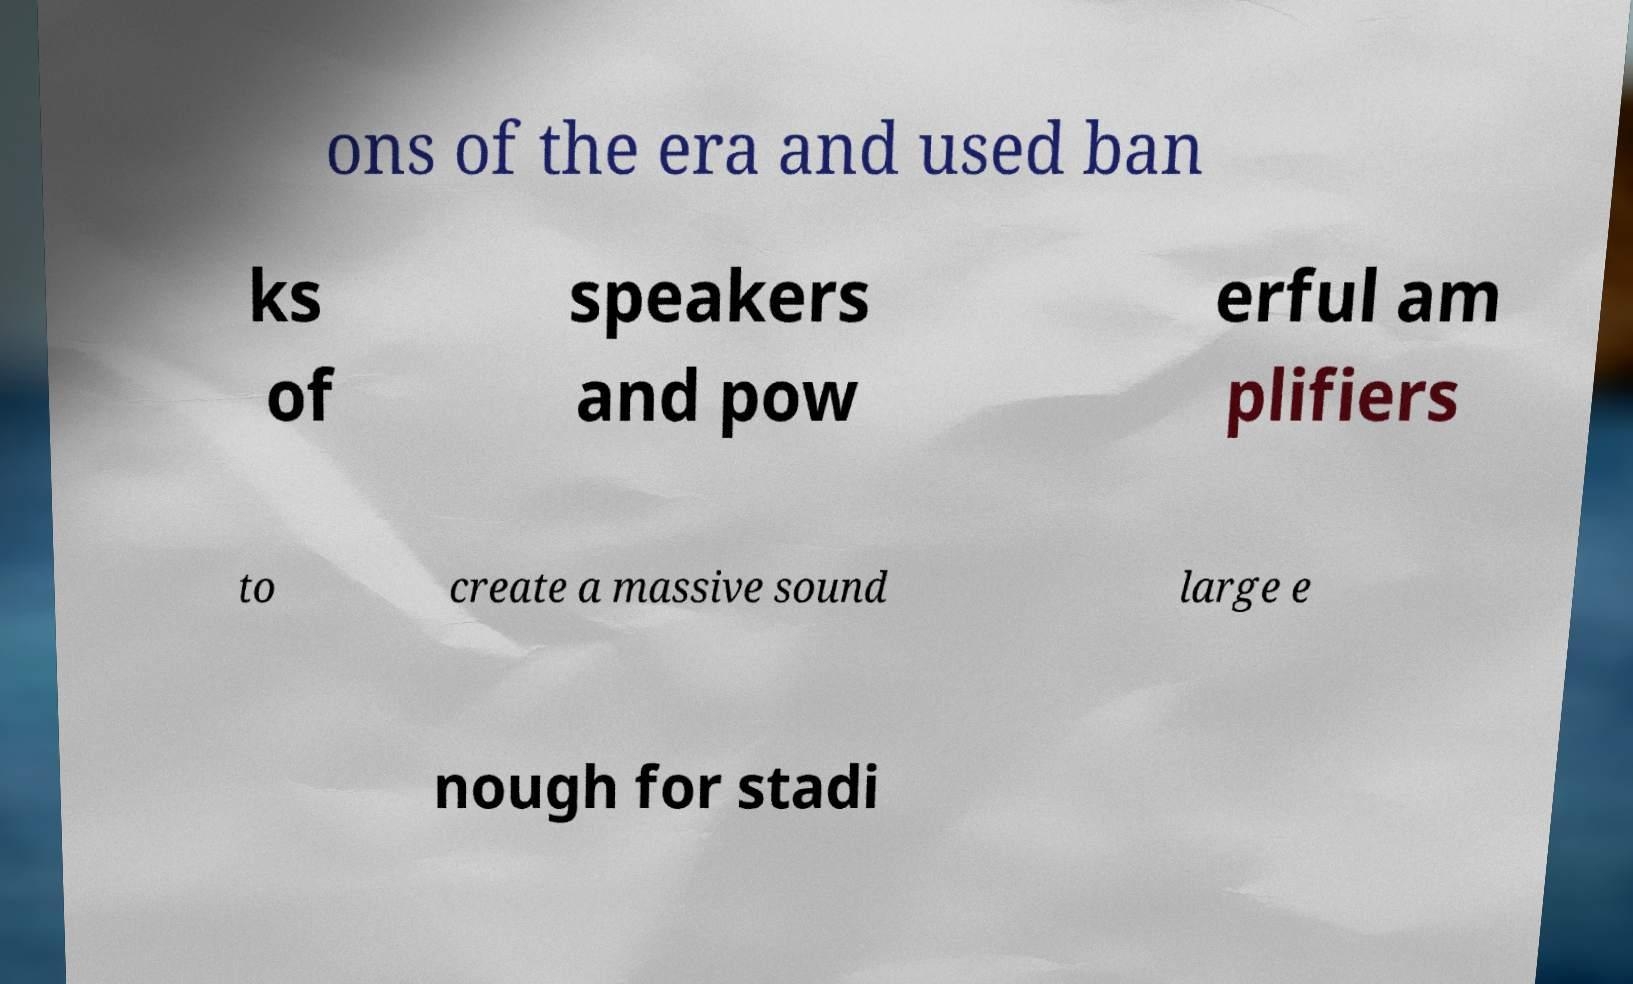Could you assist in decoding the text presented in this image and type it out clearly? ons of the era and used ban ks of speakers and pow erful am plifiers to create a massive sound large e nough for stadi 